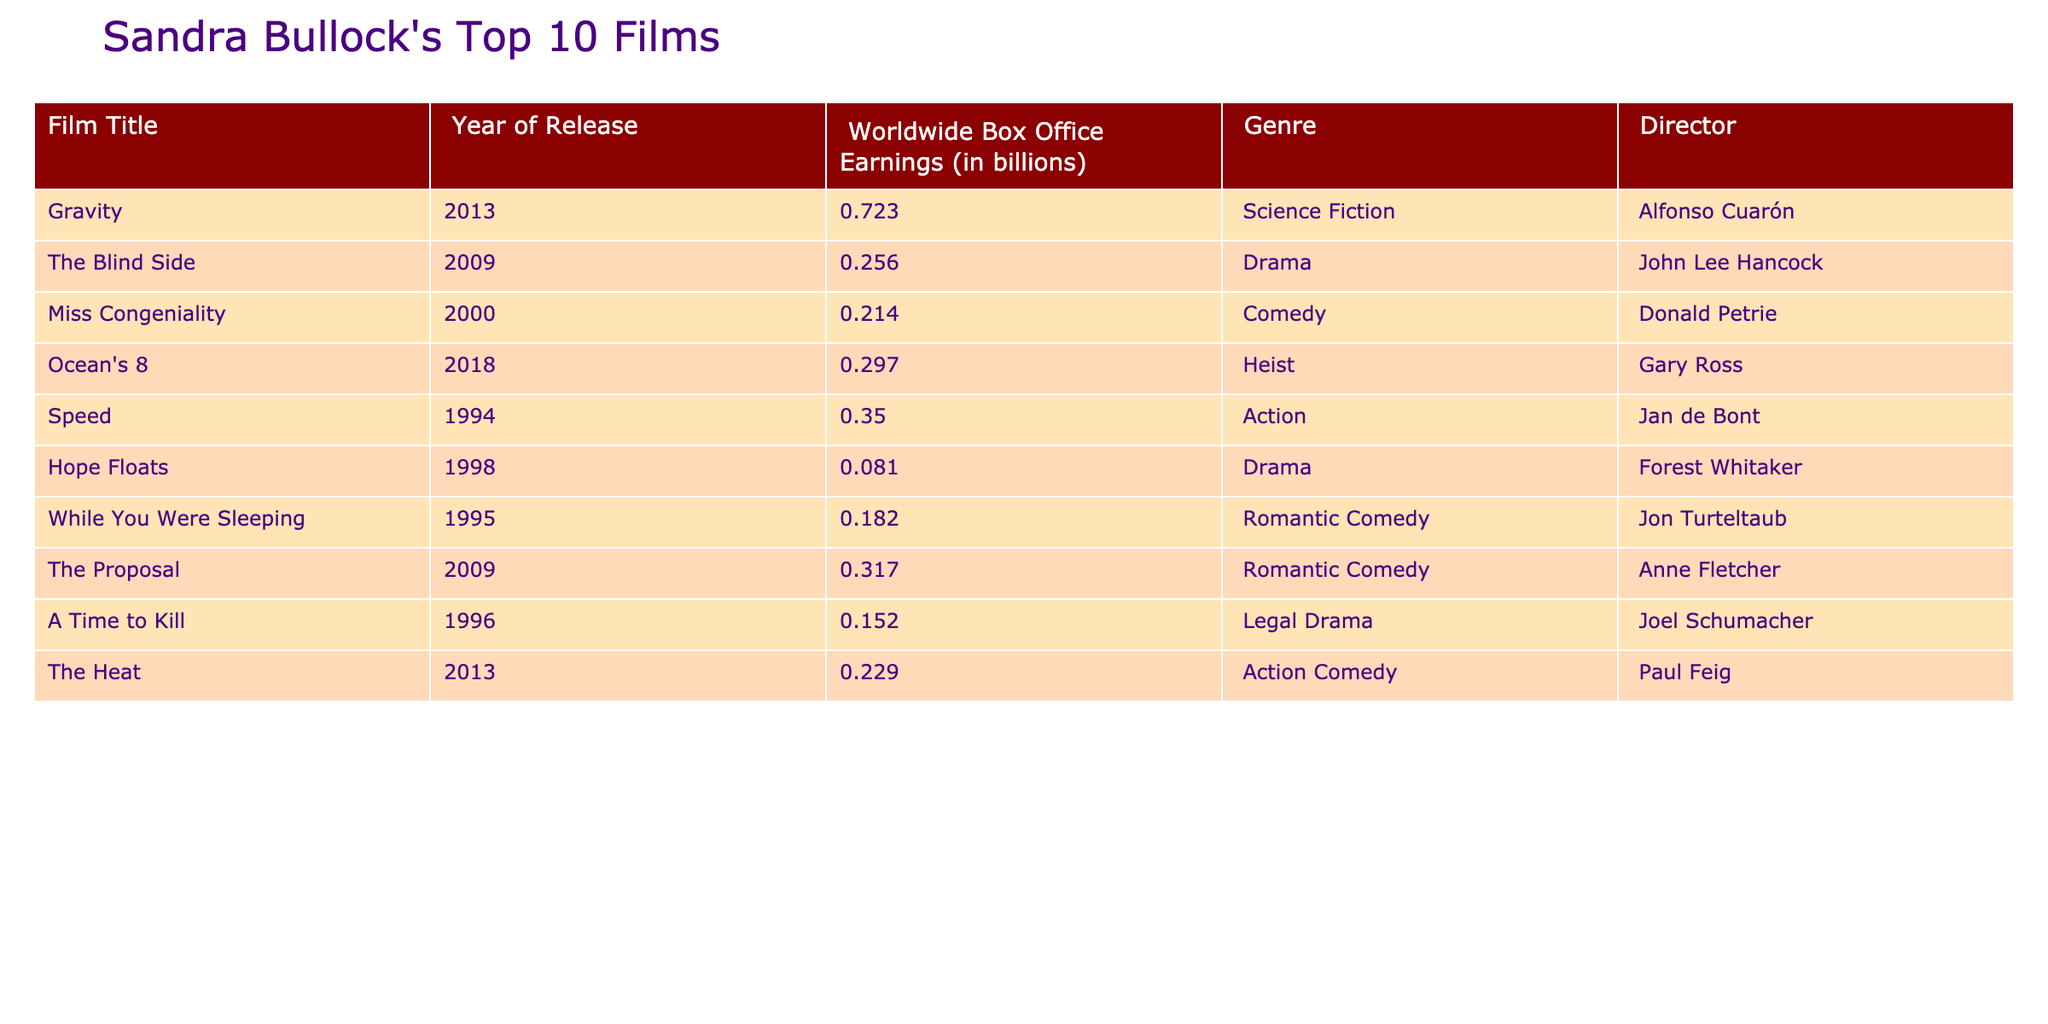What is the worldwide box office earning of Gravity? The table lists "Gravity" with a worldwide box office earning of 0.723 billion.
Answer: 0.723 billion Which film earned the least at the worldwide box office among Sandra Bullock's top 10 films? The film with the lowest earnings is "Hope Floats" with 0.081 billion.
Answer: Hope Floats What is the total worldwide box office earnings of Sandra Bullock’s top 10 films? By adding the values of all the films: 0.723 + 0.256 + 0.214 + 0.297 + 0.350 + 0.081 + 0.182 + 0.317 + 0.152 + 0.229 = 2.56 billion.
Answer: 2.56 billion Is Ocean's 8 a science fiction movie? According to the table, "Ocean's 8" is categorized as a heist, not science fiction, indicating the statement is false.
Answer: No What is the average worldwide box office earnings of the top 10 films? Sum the earnings of all films (2.56 billion) and divide by the number of films (10), so 2.56 billion / 10 = 0.256 billion.
Answer: 0.256 billion How many films in the list were directed by John Lee Hancock? There is only one film directed by John Lee Hancock and that is "The Blind Side."
Answer: 1 Which film has the highest box office earnings and what is its genre? The film with the highest earnings is "Gravity" with 0.723 billion, and its genre is science fiction.
Answer: Gravity, Science Fiction If we consider only the action genres, which film had greater earnings: Speed or The Heat? "Speed" earned 0.350 billion while "The Heat" earned 0.229 billion, thus "Speed" had greater earnings.
Answer: Speed What percentage of total earnings does The Blind Side represent? The Blind Side earned 0.256 billion, which is (0.256 / 2.56) * 100 = 10%.
Answer: 10% 